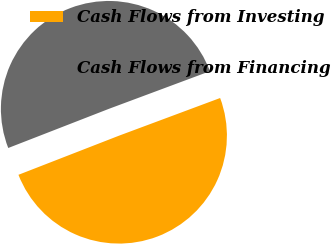Convert chart. <chart><loc_0><loc_0><loc_500><loc_500><pie_chart><fcel>Cash Flows from Investing<fcel>Cash Flows from Financing<nl><fcel>49.77%<fcel>50.23%<nl></chart> 